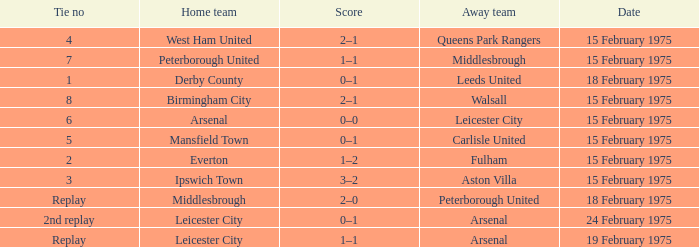What was the tie number when peterborough united was the away team? Replay. 